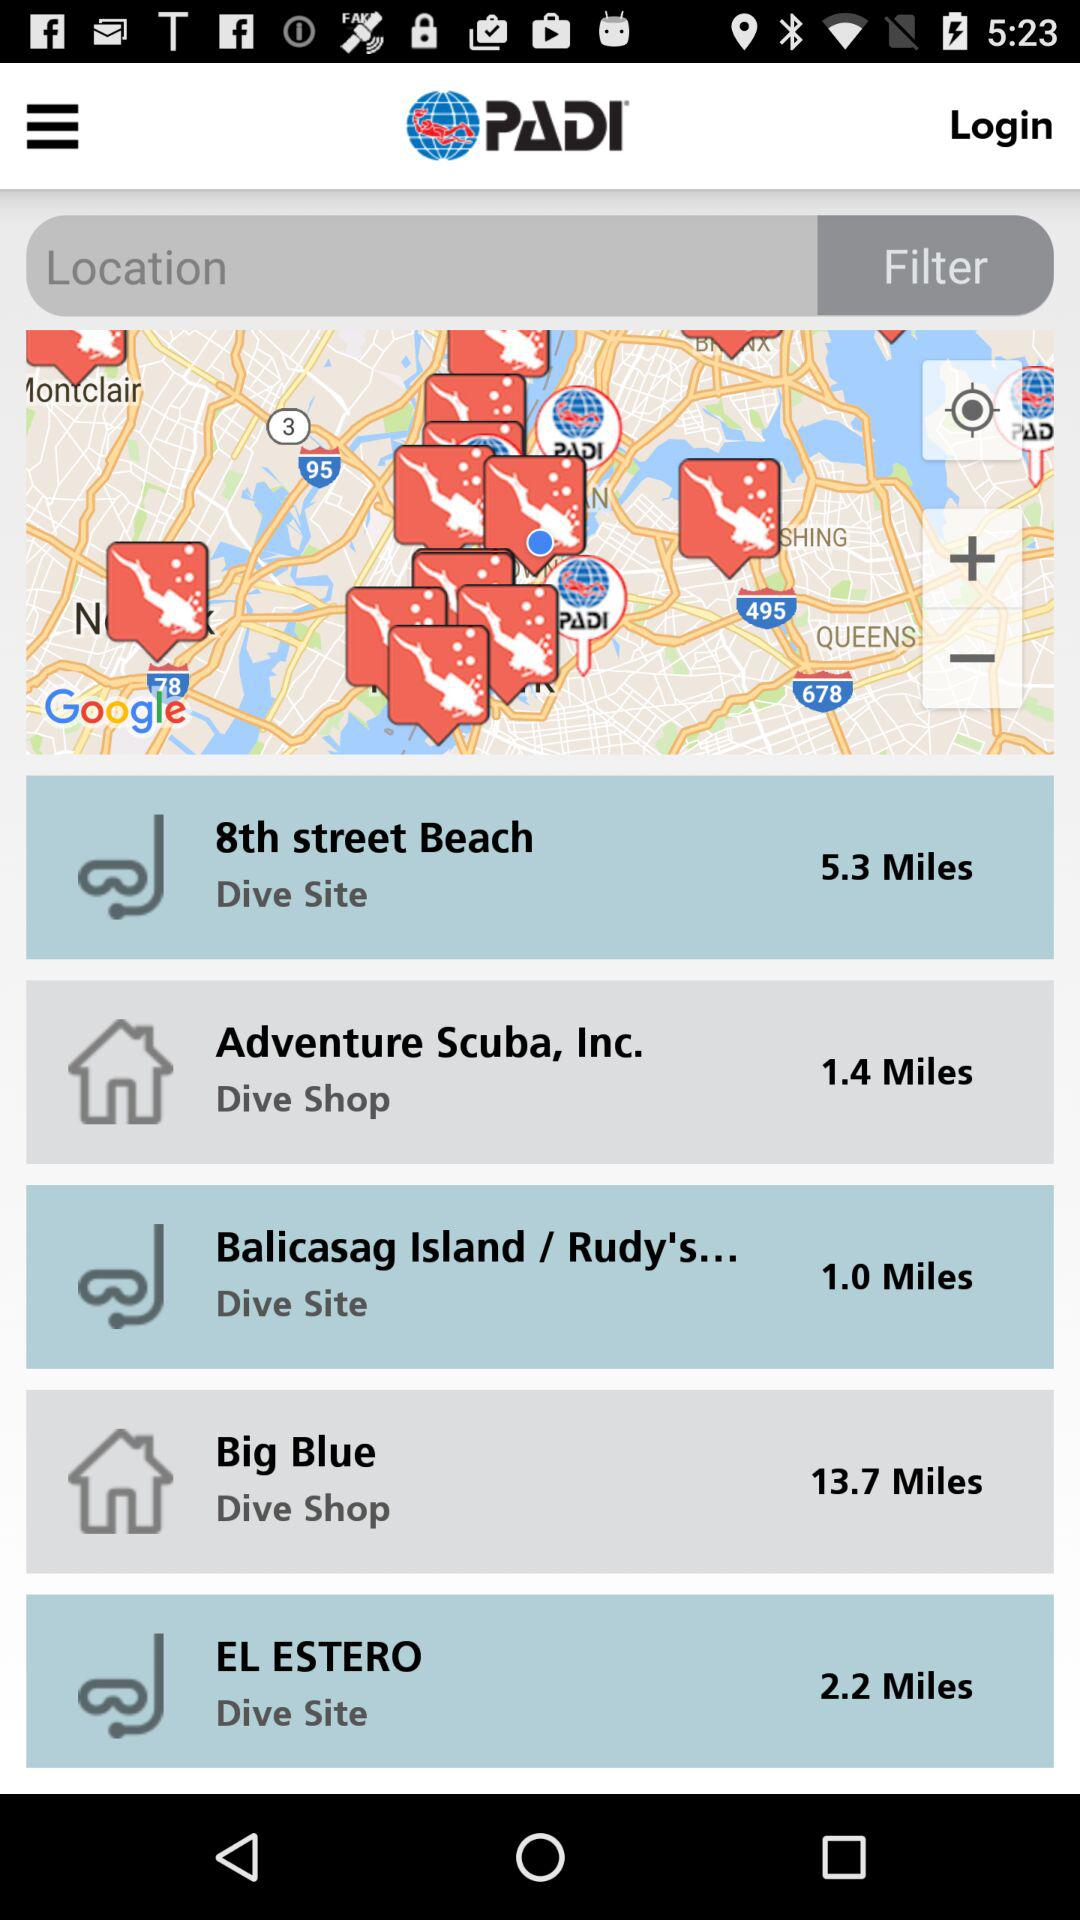How many miles away is the "Big Blue" shop? The "Big Blue" shop is 13.7 miles away. 